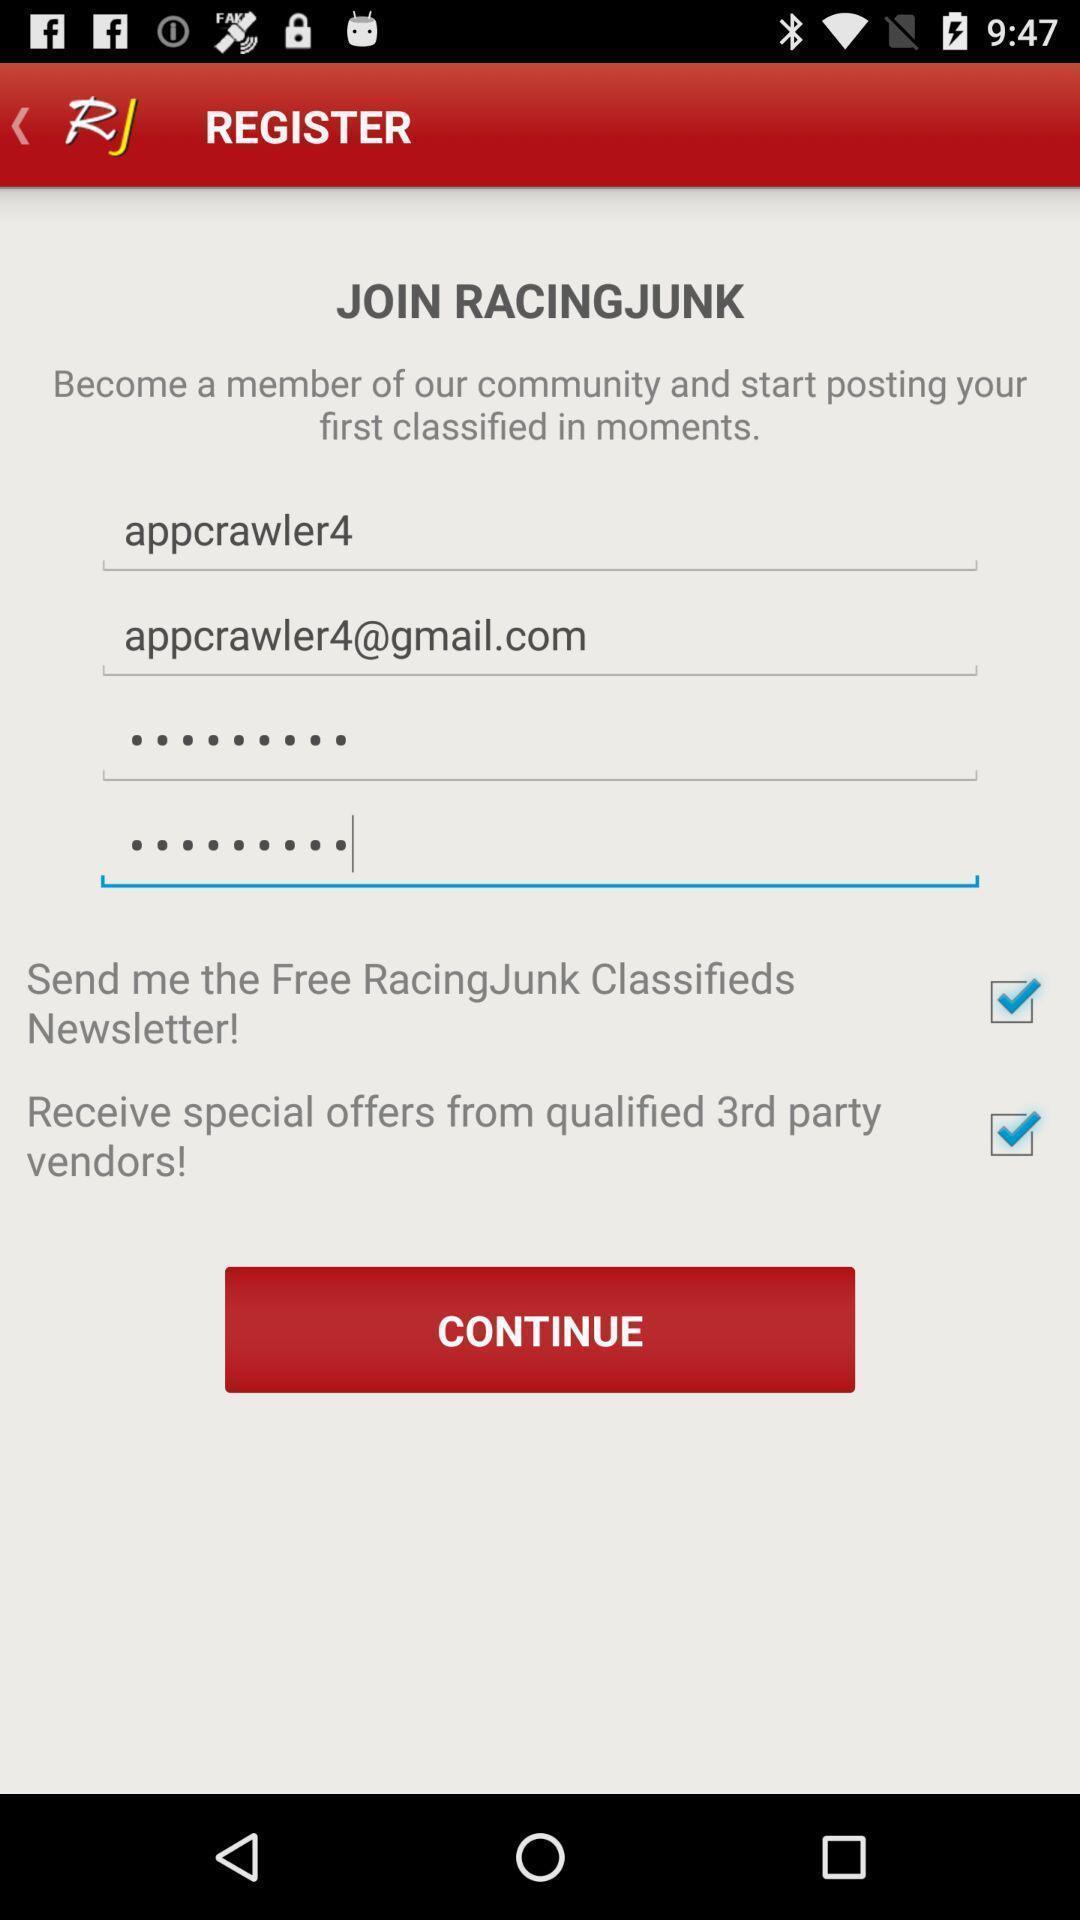Describe the content in this image. Register page to create an account. 